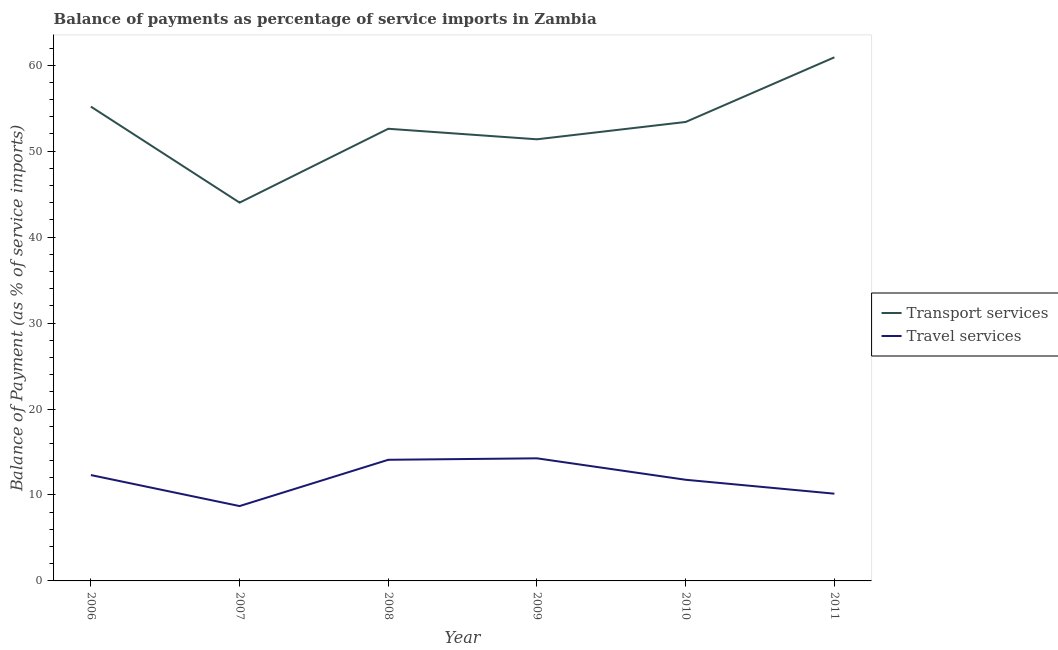What is the balance of payments of transport services in 2007?
Offer a very short reply. 44.01. Across all years, what is the maximum balance of payments of travel services?
Your answer should be compact. 14.26. Across all years, what is the minimum balance of payments of travel services?
Offer a very short reply. 8.71. In which year was the balance of payments of transport services maximum?
Keep it short and to the point. 2011. In which year was the balance of payments of travel services minimum?
Offer a terse response. 2007. What is the total balance of payments of transport services in the graph?
Your answer should be very brief. 317.5. What is the difference between the balance of payments of travel services in 2007 and that in 2010?
Your response must be concise. -3.06. What is the difference between the balance of payments of transport services in 2011 and the balance of payments of travel services in 2009?
Provide a succinct answer. 46.66. What is the average balance of payments of transport services per year?
Ensure brevity in your answer.  52.92. In the year 2007, what is the difference between the balance of payments of travel services and balance of payments of transport services?
Provide a short and direct response. -35.3. What is the ratio of the balance of payments of travel services in 2006 to that in 2009?
Offer a very short reply. 0.86. What is the difference between the highest and the second highest balance of payments of transport services?
Give a very brief answer. 5.74. What is the difference between the highest and the lowest balance of payments of travel services?
Provide a succinct answer. 5.55. In how many years, is the balance of payments of transport services greater than the average balance of payments of transport services taken over all years?
Keep it short and to the point. 3. Is the balance of payments of travel services strictly less than the balance of payments of transport services over the years?
Offer a terse response. Yes. How many years are there in the graph?
Ensure brevity in your answer.  6. Does the graph contain any zero values?
Your response must be concise. No. How are the legend labels stacked?
Give a very brief answer. Vertical. What is the title of the graph?
Your response must be concise. Balance of payments as percentage of service imports in Zambia. What is the label or title of the Y-axis?
Your answer should be compact. Balance of Payment (as % of service imports). What is the Balance of Payment (as % of service imports) in Transport services in 2006?
Provide a short and direct response. 55.18. What is the Balance of Payment (as % of service imports) in Travel services in 2006?
Make the answer very short. 12.32. What is the Balance of Payment (as % of service imports) of Transport services in 2007?
Provide a succinct answer. 44.01. What is the Balance of Payment (as % of service imports) of Travel services in 2007?
Offer a terse response. 8.71. What is the Balance of Payment (as % of service imports) of Transport services in 2008?
Your answer should be very brief. 52.61. What is the Balance of Payment (as % of service imports) in Travel services in 2008?
Your answer should be very brief. 14.09. What is the Balance of Payment (as % of service imports) in Transport services in 2009?
Keep it short and to the point. 51.38. What is the Balance of Payment (as % of service imports) in Travel services in 2009?
Your response must be concise. 14.26. What is the Balance of Payment (as % of service imports) of Transport services in 2010?
Ensure brevity in your answer.  53.4. What is the Balance of Payment (as % of service imports) in Travel services in 2010?
Provide a short and direct response. 11.77. What is the Balance of Payment (as % of service imports) in Transport services in 2011?
Provide a short and direct response. 60.92. What is the Balance of Payment (as % of service imports) in Travel services in 2011?
Give a very brief answer. 10.15. Across all years, what is the maximum Balance of Payment (as % of service imports) in Transport services?
Offer a terse response. 60.92. Across all years, what is the maximum Balance of Payment (as % of service imports) in Travel services?
Your response must be concise. 14.26. Across all years, what is the minimum Balance of Payment (as % of service imports) of Transport services?
Make the answer very short. 44.01. Across all years, what is the minimum Balance of Payment (as % of service imports) of Travel services?
Give a very brief answer. 8.71. What is the total Balance of Payment (as % of service imports) of Transport services in the graph?
Offer a very short reply. 317.5. What is the total Balance of Payment (as % of service imports) in Travel services in the graph?
Your answer should be very brief. 71.3. What is the difference between the Balance of Payment (as % of service imports) in Transport services in 2006 and that in 2007?
Offer a terse response. 11.17. What is the difference between the Balance of Payment (as % of service imports) of Travel services in 2006 and that in 2007?
Make the answer very short. 3.61. What is the difference between the Balance of Payment (as % of service imports) of Transport services in 2006 and that in 2008?
Your answer should be very brief. 2.58. What is the difference between the Balance of Payment (as % of service imports) in Travel services in 2006 and that in 2008?
Ensure brevity in your answer.  -1.78. What is the difference between the Balance of Payment (as % of service imports) of Transport services in 2006 and that in 2009?
Provide a succinct answer. 3.8. What is the difference between the Balance of Payment (as % of service imports) of Travel services in 2006 and that in 2009?
Offer a terse response. -1.95. What is the difference between the Balance of Payment (as % of service imports) in Transport services in 2006 and that in 2010?
Provide a short and direct response. 1.79. What is the difference between the Balance of Payment (as % of service imports) of Travel services in 2006 and that in 2010?
Your answer should be compact. 0.55. What is the difference between the Balance of Payment (as % of service imports) of Transport services in 2006 and that in 2011?
Offer a terse response. -5.74. What is the difference between the Balance of Payment (as % of service imports) of Travel services in 2006 and that in 2011?
Offer a very short reply. 2.17. What is the difference between the Balance of Payment (as % of service imports) in Transport services in 2007 and that in 2008?
Offer a terse response. -8.59. What is the difference between the Balance of Payment (as % of service imports) in Travel services in 2007 and that in 2008?
Offer a very short reply. -5.39. What is the difference between the Balance of Payment (as % of service imports) in Transport services in 2007 and that in 2009?
Provide a short and direct response. -7.37. What is the difference between the Balance of Payment (as % of service imports) of Travel services in 2007 and that in 2009?
Provide a short and direct response. -5.55. What is the difference between the Balance of Payment (as % of service imports) of Transport services in 2007 and that in 2010?
Offer a very short reply. -9.38. What is the difference between the Balance of Payment (as % of service imports) of Travel services in 2007 and that in 2010?
Make the answer very short. -3.06. What is the difference between the Balance of Payment (as % of service imports) in Transport services in 2007 and that in 2011?
Provide a short and direct response. -16.91. What is the difference between the Balance of Payment (as % of service imports) of Travel services in 2007 and that in 2011?
Your answer should be compact. -1.44. What is the difference between the Balance of Payment (as % of service imports) in Transport services in 2008 and that in 2009?
Make the answer very short. 1.23. What is the difference between the Balance of Payment (as % of service imports) of Travel services in 2008 and that in 2009?
Offer a very short reply. -0.17. What is the difference between the Balance of Payment (as % of service imports) in Transport services in 2008 and that in 2010?
Keep it short and to the point. -0.79. What is the difference between the Balance of Payment (as % of service imports) of Travel services in 2008 and that in 2010?
Give a very brief answer. 2.33. What is the difference between the Balance of Payment (as % of service imports) of Transport services in 2008 and that in 2011?
Your response must be concise. -8.31. What is the difference between the Balance of Payment (as % of service imports) in Travel services in 2008 and that in 2011?
Provide a succinct answer. 3.94. What is the difference between the Balance of Payment (as % of service imports) in Transport services in 2009 and that in 2010?
Give a very brief answer. -2.02. What is the difference between the Balance of Payment (as % of service imports) in Travel services in 2009 and that in 2010?
Your answer should be very brief. 2.5. What is the difference between the Balance of Payment (as % of service imports) in Transport services in 2009 and that in 2011?
Provide a short and direct response. -9.54. What is the difference between the Balance of Payment (as % of service imports) in Travel services in 2009 and that in 2011?
Ensure brevity in your answer.  4.11. What is the difference between the Balance of Payment (as % of service imports) in Transport services in 2010 and that in 2011?
Offer a terse response. -7.52. What is the difference between the Balance of Payment (as % of service imports) of Travel services in 2010 and that in 2011?
Provide a succinct answer. 1.62. What is the difference between the Balance of Payment (as % of service imports) in Transport services in 2006 and the Balance of Payment (as % of service imports) in Travel services in 2007?
Make the answer very short. 46.47. What is the difference between the Balance of Payment (as % of service imports) in Transport services in 2006 and the Balance of Payment (as % of service imports) in Travel services in 2008?
Your answer should be very brief. 41.09. What is the difference between the Balance of Payment (as % of service imports) of Transport services in 2006 and the Balance of Payment (as % of service imports) of Travel services in 2009?
Make the answer very short. 40.92. What is the difference between the Balance of Payment (as % of service imports) of Transport services in 2006 and the Balance of Payment (as % of service imports) of Travel services in 2010?
Your answer should be very brief. 43.41. What is the difference between the Balance of Payment (as % of service imports) in Transport services in 2006 and the Balance of Payment (as % of service imports) in Travel services in 2011?
Your answer should be compact. 45.03. What is the difference between the Balance of Payment (as % of service imports) of Transport services in 2007 and the Balance of Payment (as % of service imports) of Travel services in 2008?
Offer a terse response. 29.92. What is the difference between the Balance of Payment (as % of service imports) of Transport services in 2007 and the Balance of Payment (as % of service imports) of Travel services in 2009?
Your answer should be compact. 29.75. What is the difference between the Balance of Payment (as % of service imports) of Transport services in 2007 and the Balance of Payment (as % of service imports) of Travel services in 2010?
Your answer should be very brief. 32.25. What is the difference between the Balance of Payment (as % of service imports) of Transport services in 2007 and the Balance of Payment (as % of service imports) of Travel services in 2011?
Your answer should be very brief. 33.86. What is the difference between the Balance of Payment (as % of service imports) of Transport services in 2008 and the Balance of Payment (as % of service imports) of Travel services in 2009?
Provide a short and direct response. 38.34. What is the difference between the Balance of Payment (as % of service imports) in Transport services in 2008 and the Balance of Payment (as % of service imports) in Travel services in 2010?
Give a very brief answer. 40.84. What is the difference between the Balance of Payment (as % of service imports) of Transport services in 2008 and the Balance of Payment (as % of service imports) of Travel services in 2011?
Your answer should be very brief. 42.46. What is the difference between the Balance of Payment (as % of service imports) of Transport services in 2009 and the Balance of Payment (as % of service imports) of Travel services in 2010?
Your response must be concise. 39.61. What is the difference between the Balance of Payment (as % of service imports) in Transport services in 2009 and the Balance of Payment (as % of service imports) in Travel services in 2011?
Your response must be concise. 41.23. What is the difference between the Balance of Payment (as % of service imports) of Transport services in 2010 and the Balance of Payment (as % of service imports) of Travel services in 2011?
Ensure brevity in your answer.  43.25. What is the average Balance of Payment (as % of service imports) in Transport services per year?
Provide a succinct answer. 52.92. What is the average Balance of Payment (as % of service imports) in Travel services per year?
Provide a succinct answer. 11.88. In the year 2006, what is the difference between the Balance of Payment (as % of service imports) in Transport services and Balance of Payment (as % of service imports) in Travel services?
Your response must be concise. 42.87. In the year 2007, what is the difference between the Balance of Payment (as % of service imports) in Transport services and Balance of Payment (as % of service imports) in Travel services?
Offer a terse response. 35.3. In the year 2008, what is the difference between the Balance of Payment (as % of service imports) of Transport services and Balance of Payment (as % of service imports) of Travel services?
Give a very brief answer. 38.51. In the year 2009, what is the difference between the Balance of Payment (as % of service imports) in Transport services and Balance of Payment (as % of service imports) in Travel services?
Your answer should be compact. 37.12. In the year 2010, what is the difference between the Balance of Payment (as % of service imports) in Transport services and Balance of Payment (as % of service imports) in Travel services?
Keep it short and to the point. 41.63. In the year 2011, what is the difference between the Balance of Payment (as % of service imports) in Transport services and Balance of Payment (as % of service imports) in Travel services?
Your answer should be very brief. 50.77. What is the ratio of the Balance of Payment (as % of service imports) of Transport services in 2006 to that in 2007?
Make the answer very short. 1.25. What is the ratio of the Balance of Payment (as % of service imports) in Travel services in 2006 to that in 2007?
Offer a very short reply. 1.41. What is the ratio of the Balance of Payment (as % of service imports) of Transport services in 2006 to that in 2008?
Offer a very short reply. 1.05. What is the ratio of the Balance of Payment (as % of service imports) of Travel services in 2006 to that in 2008?
Ensure brevity in your answer.  0.87. What is the ratio of the Balance of Payment (as % of service imports) in Transport services in 2006 to that in 2009?
Your response must be concise. 1.07. What is the ratio of the Balance of Payment (as % of service imports) of Travel services in 2006 to that in 2009?
Provide a short and direct response. 0.86. What is the ratio of the Balance of Payment (as % of service imports) of Transport services in 2006 to that in 2010?
Give a very brief answer. 1.03. What is the ratio of the Balance of Payment (as % of service imports) in Travel services in 2006 to that in 2010?
Make the answer very short. 1.05. What is the ratio of the Balance of Payment (as % of service imports) in Transport services in 2006 to that in 2011?
Keep it short and to the point. 0.91. What is the ratio of the Balance of Payment (as % of service imports) of Travel services in 2006 to that in 2011?
Provide a short and direct response. 1.21. What is the ratio of the Balance of Payment (as % of service imports) in Transport services in 2007 to that in 2008?
Offer a very short reply. 0.84. What is the ratio of the Balance of Payment (as % of service imports) in Travel services in 2007 to that in 2008?
Provide a short and direct response. 0.62. What is the ratio of the Balance of Payment (as % of service imports) in Transport services in 2007 to that in 2009?
Make the answer very short. 0.86. What is the ratio of the Balance of Payment (as % of service imports) in Travel services in 2007 to that in 2009?
Offer a very short reply. 0.61. What is the ratio of the Balance of Payment (as % of service imports) of Transport services in 2007 to that in 2010?
Your response must be concise. 0.82. What is the ratio of the Balance of Payment (as % of service imports) in Travel services in 2007 to that in 2010?
Offer a very short reply. 0.74. What is the ratio of the Balance of Payment (as % of service imports) of Transport services in 2007 to that in 2011?
Offer a terse response. 0.72. What is the ratio of the Balance of Payment (as % of service imports) of Travel services in 2007 to that in 2011?
Ensure brevity in your answer.  0.86. What is the ratio of the Balance of Payment (as % of service imports) in Transport services in 2008 to that in 2009?
Ensure brevity in your answer.  1.02. What is the ratio of the Balance of Payment (as % of service imports) in Transport services in 2008 to that in 2010?
Your response must be concise. 0.99. What is the ratio of the Balance of Payment (as % of service imports) in Travel services in 2008 to that in 2010?
Offer a very short reply. 1.2. What is the ratio of the Balance of Payment (as % of service imports) of Transport services in 2008 to that in 2011?
Offer a terse response. 0.86. What is the ratio of the Balance of Payment (as % of service imports) of Travel services in 2008 to that in 2011?
Your answer should be compact. 1.39. What is the ratio of the Balance of Payment (as % of service imports) of Transport services in 2009 to that in 2010?
Your response must be concise. 0.96. What is the ratio of the Balance of Payment (as % of service imports) in Travel services in 2009 to that in 2010?
Ensure brevity in your answer.  1.21. What is the ratio of the Balance of Payment (as % of service imports) in Transport services in 2009 to that in 2011?
Offer a very short reply. 0.84. What is the ratio of the Balance of Payment (as % of service imports) of Travel services in 2009 to that in 2011?
Your answer should be compact. 1.41. What is the ratio of the Balance of Payment (as % of service imports) in Transport services in 2010 to that in 2011?
Keep it short and to the point. 0.88. What is the ratio of the Balance of Payment (as % of service imports) in Travel services in 2010 to that in 2011?
Your answer should be very brief. 1.16. What is the difference between the highest and the second highest Balance of Payment (as % of service imports) in Transport services?
Provide a succinct answer. 5.74. What is the difference between the highest and the second highest Balance of Payment (as % of service imports) of Travel services?
Keep it short and to the point. 0.17. What is the difference between the highest and the lowest Balance of Payment (as % of service imports) of Transport services?
Keep it short and to the point. 16.91. What is the difference between the highest and the lowest Balance of Payment (as % of service imports) in Travel services?
Keep it short and to the point. 5.55. 